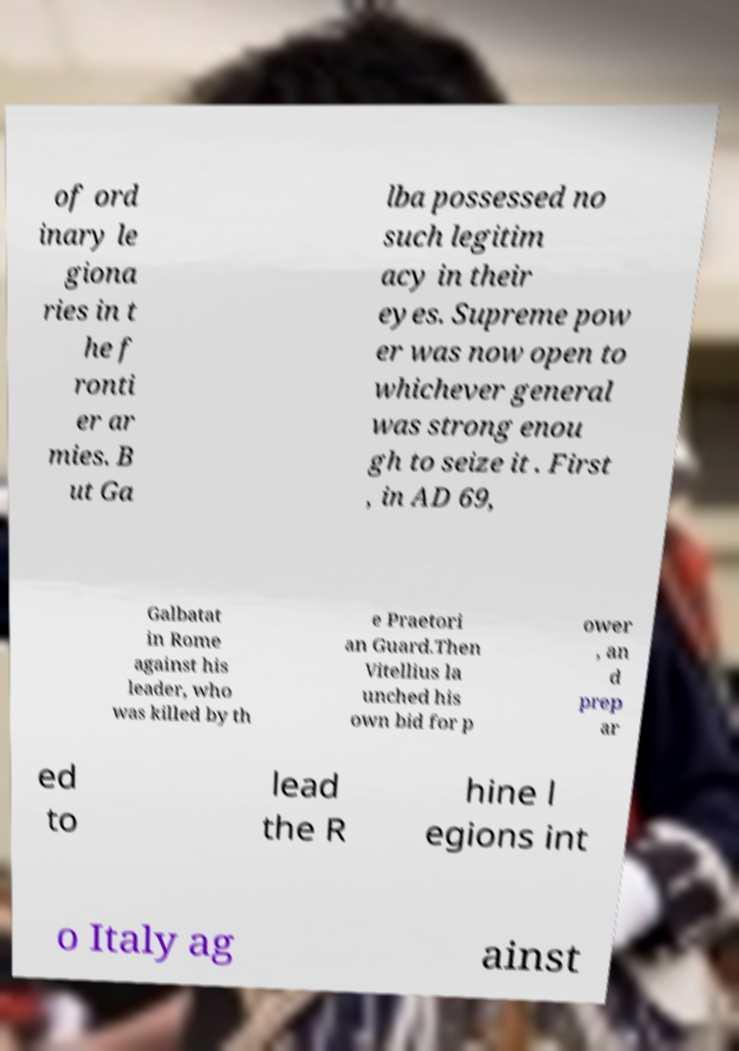Could you assist in decoding the text presented in this image and type it out clearly? of ord inary le giona ries in t he f ronti er ar mies. B ut Ga lba possessed no such legitim acy in their eyes. Supreme pow er was now open to whichever general was strong enou gh to seize it . First , in AD 69, Galbatat in Rome against his leader, who was killed by th e Praetori an Guard.Then Vitellius la unched his own bid for p ower , an d prep ar ed to lead the R hine l egions int o Italy ag ainst 